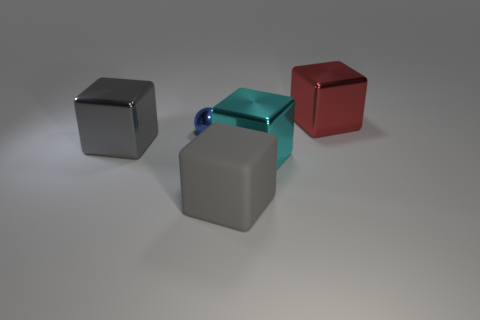Do the metal block to the left of the large cyan cube and the big rubber block have the same color?
Your response must be concise. Yes. There is a metal thing that is the same color as the rubber object; what size is it?
Keep it short and to the point. Large. What material is the gray block that is on the right side of the big shiny object on the left side of the cyan thing?
Give a very brief answer. Rubber. Are there any large red things behind the blue ball?
Give a very brief answer. Yes. Are there more small shiny spheres that are behind the blue sphere than big green blocks?
Ensure brevity in your answer.  No. Is there a metallic block of the same color as the tiny metallic object?
Make the answer very short. No. There is a rubber thing that is the same size as the gray shiny object; what color is it?
Provide a short and direct response. Gray. Are there any big cyan things to the left of the large gray cube behind the gray matte cube?
Keep it short and to the point. No. What is the big gray cube that is to the right of the gray metal cube made of?
Keep it short and to the point. Rubber. Is the gray cube on the right side of the big gray shiny cube made of the same material as the large cube left of the tiny shiny object?
Your response must be concise. No. 